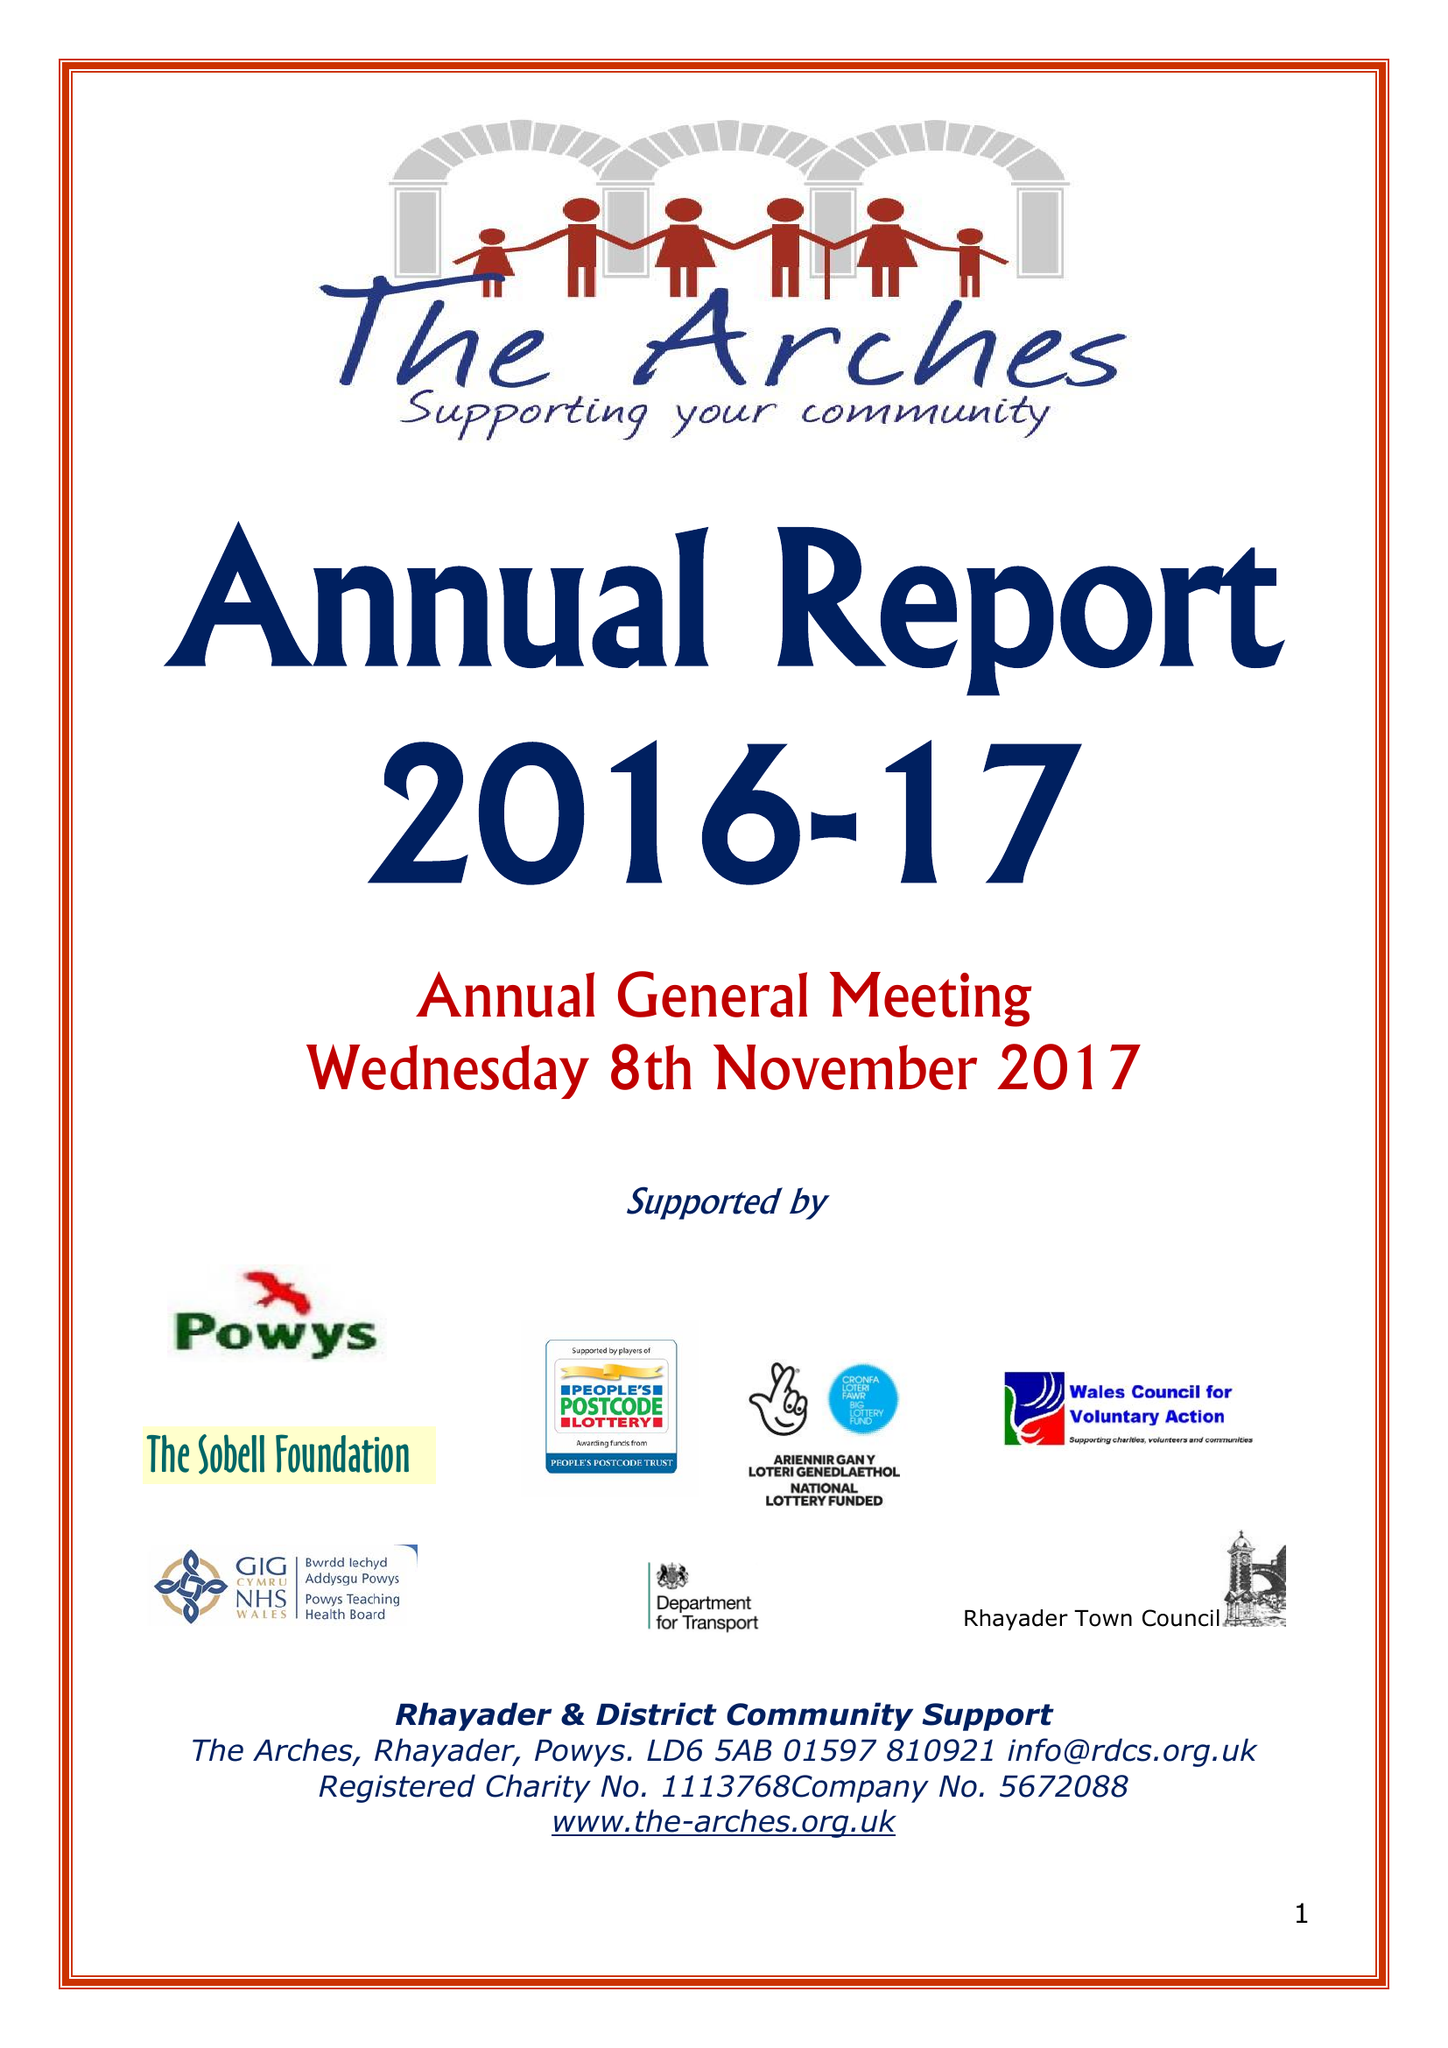What is the value for the address__postcode?
Answer the question using a single word or phrase. LD6 5AB 